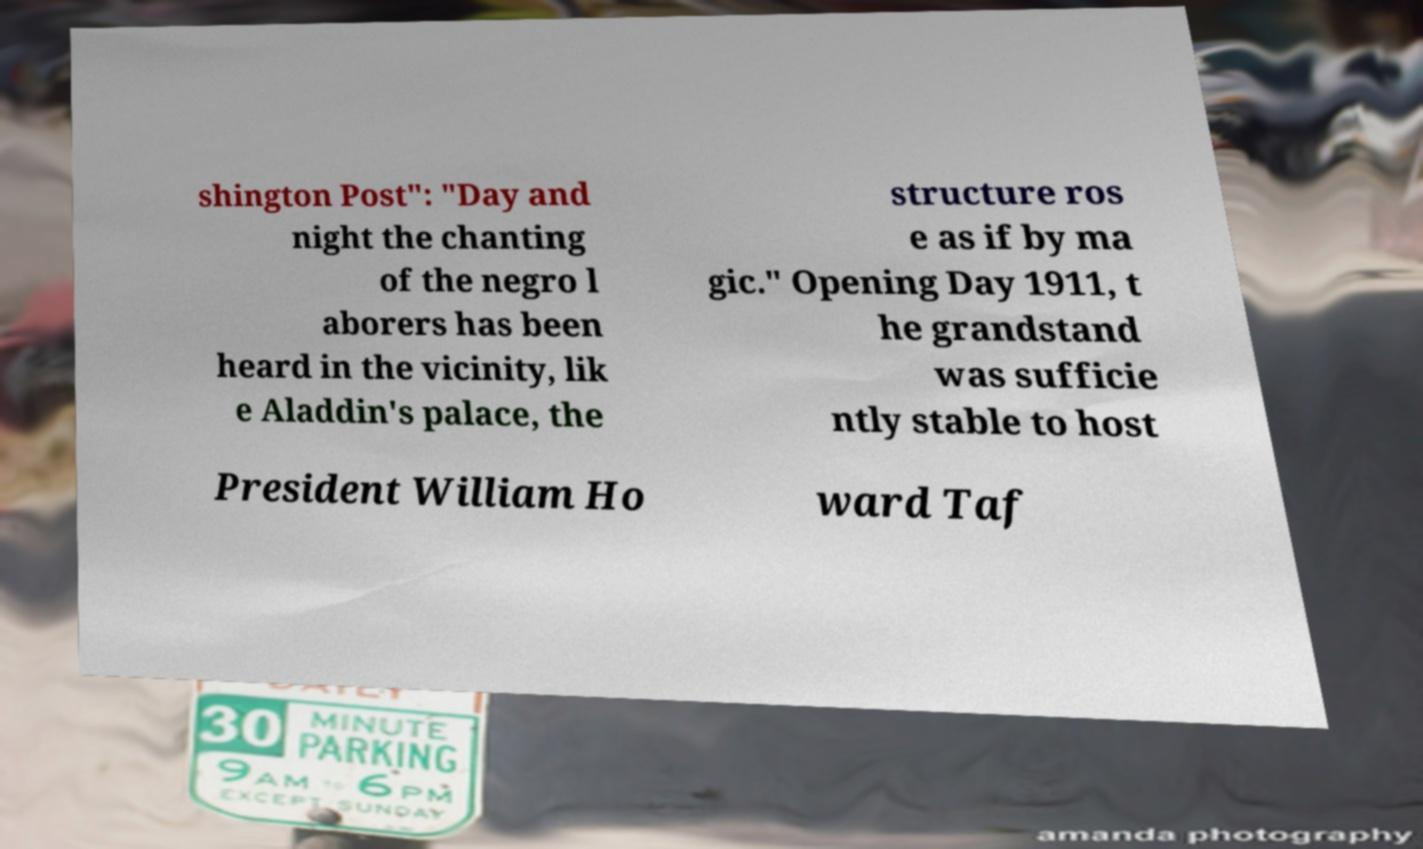Can you read and provide the text displayed in the image?This photo seems to have some interesting text. Can you extract and type it out for me? shington Post": "Day and night the chanting of the negro l aborers has been heard in the vicinity, lik e Aladdin's palace, the structure ros e as if by ma gic." Opening Day 1911, t he grandstand was sufficie ntly stable to host President William Ho ward Taf 